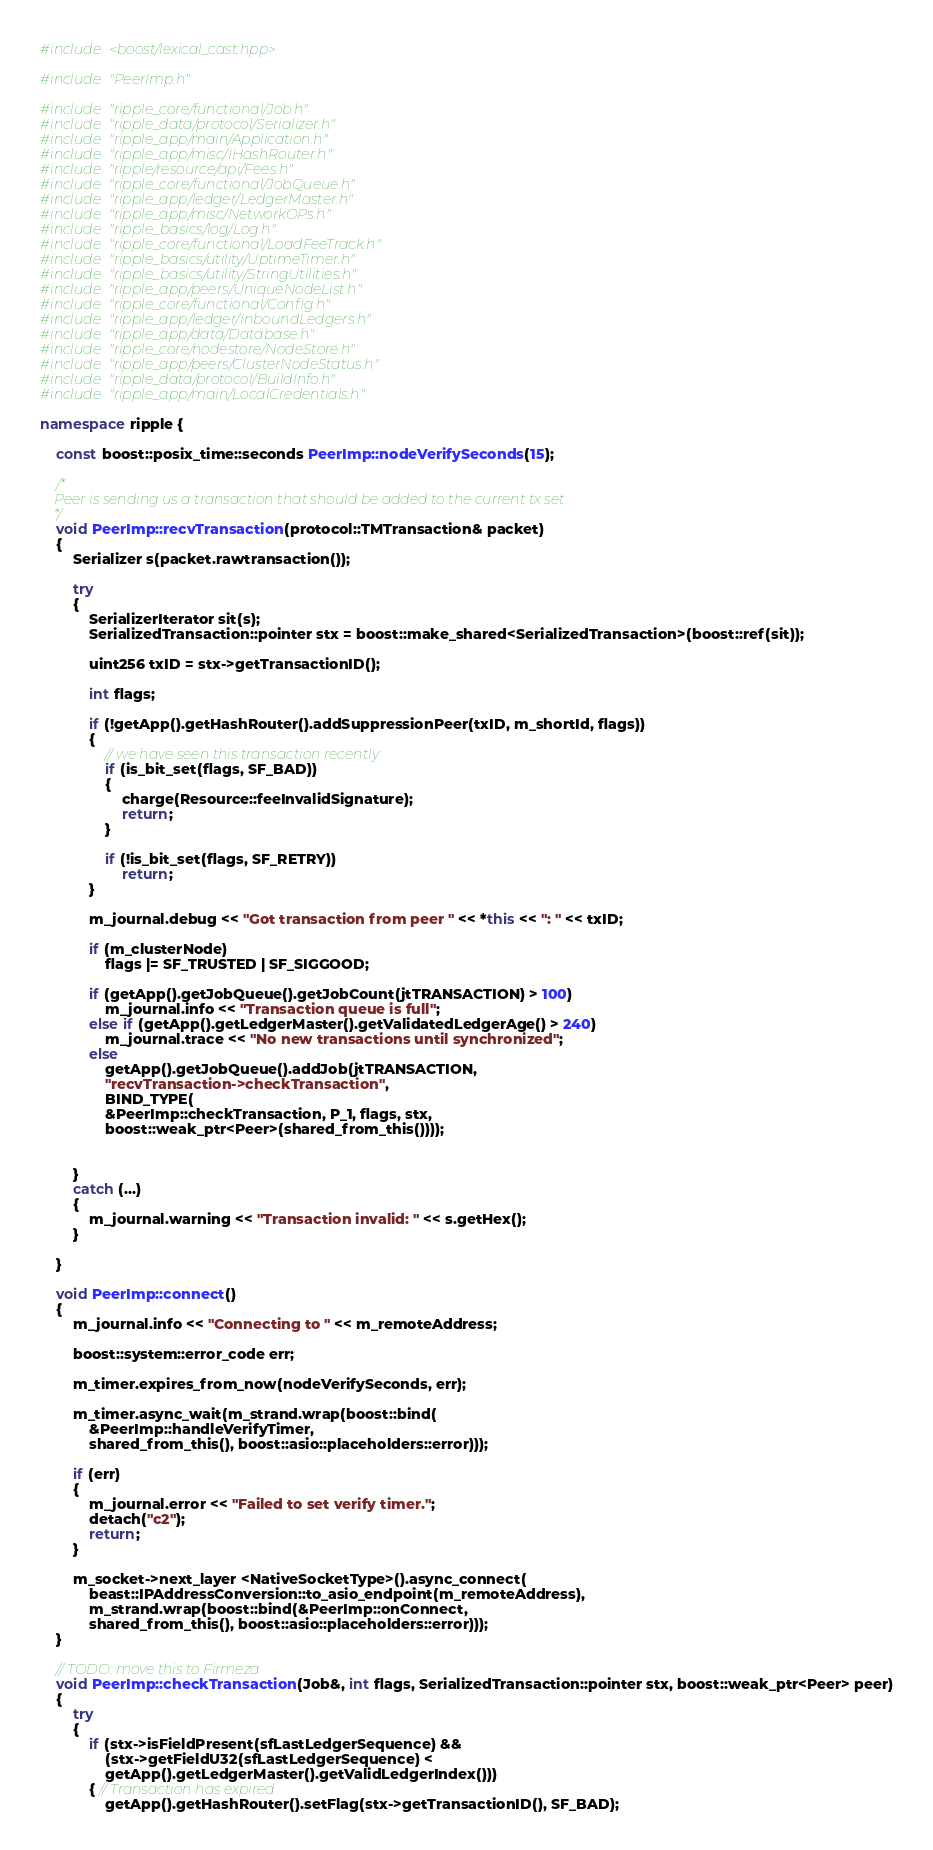<code> <loc_0><loc_0><loc_500><loc_500><_C++_>#include <boost/lexical_cast.hpp>

#include "PeerImp.h"

#include "ripple_core/functional/Job.h"
#include "ripple_data/protocol/Serializer.h"
#include "ripple_app/main/Application.h"
#include "ripple_app/misc/IHashRouter.h"
#include "ripple/resource/api/Fees.h"
#include "ripple_core/functional/JobQueue.h"
#include "ripple_app/ledger/LedgerMaster.h"
#include "ripple_app/misc/NetworkOPs.h"
#include "ripple_basics/log/Log.h"
#include "ripple_core/functional/LoadFeeTrack.h"
#include "ripple_basics/utility/UptimeTimer.h"
#include "ripple_basics/utility/StringUtilities.h"
#include "ripple_app/peers/UniqueNodeList.h"
#include "ripple_core/functional/Config.h"
#include "ripple_app/ledger/InboundLedgers.h"
#include "ripple_app/data/Database.h"
#include "ripple_core/nodestore/NodeStore.h"
#include "ripple_app/peers/ClusterNodeStatus.h"
#include "ripple_data/protocol/BuildInfo.h"
#include "ripple_app/main/LocalCredentials.h"

namespace ripple {

	const boost::posix_time::seconds PeerImp::nodeVerifySeconds(15);

	/*
	Peer is sending us a transaction that should be added to the current tx set
	*/
	void PeerImp::recvTransaction(protocol::TMTransaction& packet)
	{
		Serializer s(packet.rawtransaction());

		try
		{	
			SerializerIterator sit(s);
			SerializedTransaction::pointer stx = boost::make_shared<SerializedTransaction>(boost::ref(sit));

			uint256 txID = stx->getTransactionID();

			int flags;

			if (!getApp().getHashRouter().addSuppressionPeer(txID, m_shortId, flags))
			{
				// we have seen this transaction recently
				if (is_bit_set(flags, SF_BAD))
				{
					charge(Resource::feeInvalidSignature);
					return;
				}

				if (!is_bit_set(flags, SF_RETRY))
					return;
			}

			m_journal.debug << "Got transaction from peer " << *this << ": " << txID;

			if (m_clusterNode)
				flags |= SF_TRUSTED | SF_SIGGOOD;

			if (getApp().getJobQueue().getJobCount(jtTRANSACTION) > 100)
				m_journal.info << "Transaction queue is full";
			else if (getApp().getLedgerMaster().getValidatedLedgerAge() > 240)
				m_journal.trace << "No new transactions until synchronized";
			else
				getApp().getJobQueue().addJob(jtTRANSACTION,
				"recvTransaction->checkTransaction",
				BIND_TYPE(
				&PeerImp::checkTransaction, P_1, flags, stx,
				boost::weak_ptr<Peer>(shared_from_this())));


		}
		catch (...)
		{
			m_journal.warning << "Transaction invalid: " << s.getHex();
		}

	}

	void PeerImp::connect()
	{
		m_journal.info << "Connecting to " << m_remoteAddress;

		boost::system::error_code err;

		m_timer.expires_from_now(nodeVerifySeconds, err);

		m_timer.async_wait(m_strand.wrap(boost::bind(
			&PeerImp::handleVerifyTimer,
			shared_from_this(), boost::asio::placeholders::error)));

		if (err)
		{
			m_journal.error << "Failed to set verify timer.";
			detach("c2");
			return;
		}

		m_socket->next_layer <NativeSocketType>().async_connect(
			beast::IPAddressConversion::to_asio_endpoint(m_remoteAddress),
			m_strand.wrap(boost::bind(&PeerImp::onConnect,
			shared_from_this(), boost::asio::placeholders::error)));
	}

	// TODO: move this to Firmeza
	void PeerImp::checkTransaction(Job&, int flags, SerializedTransaction::pointer stx, boost::weak_ptr<Peer> peer)
	{
		try
		{
			if (stx->isFieldPresent(sfLastLedgerSequence) &&
				(stx->getFieldU32(sfLastLedgerSequence) <
				getApp().getLedgerMaster().getValidLedgerIndex()))
			{ // Transaction has expired
				getApp().getHashRouter().setFlag(stx->getTransactionID(), SF_BAD);</code> 